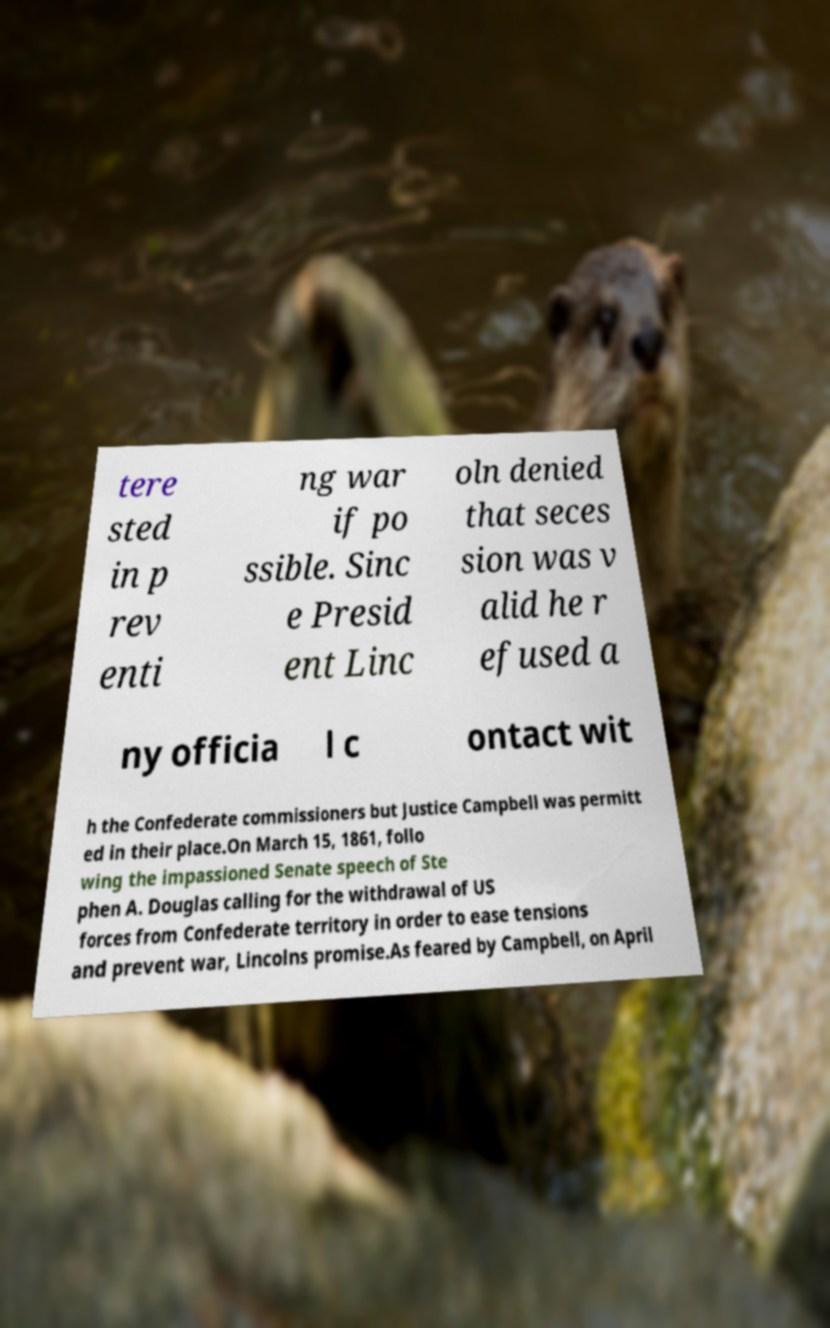Can you read and provide the text displayed in the image?This photo seems to have some interesting text. Can you extract and type it out for me? tere sted in p rev enti ng war if po ssible. Sinc e Presid ent Linc oln denied that seces sion was v alid he r efused a ny officia l c ontact wit h the Confederate commissioners but Justice Campbell was permitt ed in their place.On March 15, 1861, follo wing the impassioned Senate speech of Ste phen A. Douglas calling for the withdrawal of US forces from Confederate territory in order to ease tensions and prevent war, Lincolns promise.As feared by Campbell, on April 